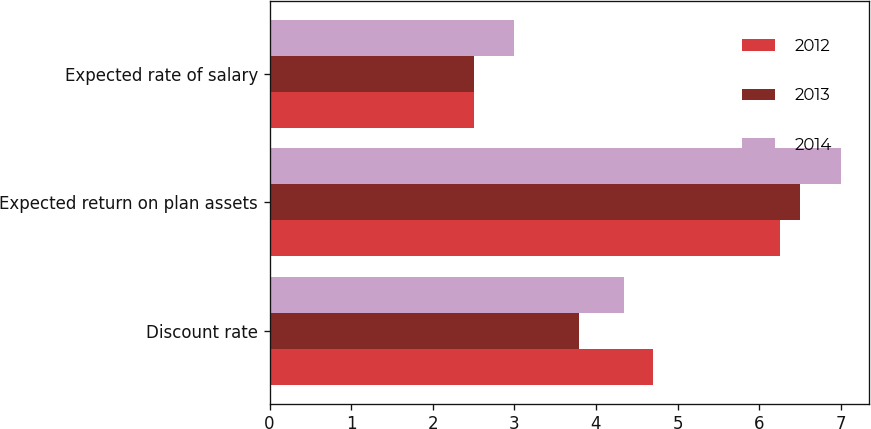Convert chart to OTSL. <chart><loc_0><loc_0><loc_500><loc_500><stacked_bar_chart><ecel><fcel>Discount rate<fcel>Expected return on plan assets<fcel>Expected rate of salary<nl><fcel>2012<fcel>4.7<fcel>6.25<fcel>2.5<nl><fcel>2013<fcel>3.79<fcel>6.5<fcel>2.5<nl><fcel>2014<fcel>4.34<fcel>7<fcel>3<nl></chart> 